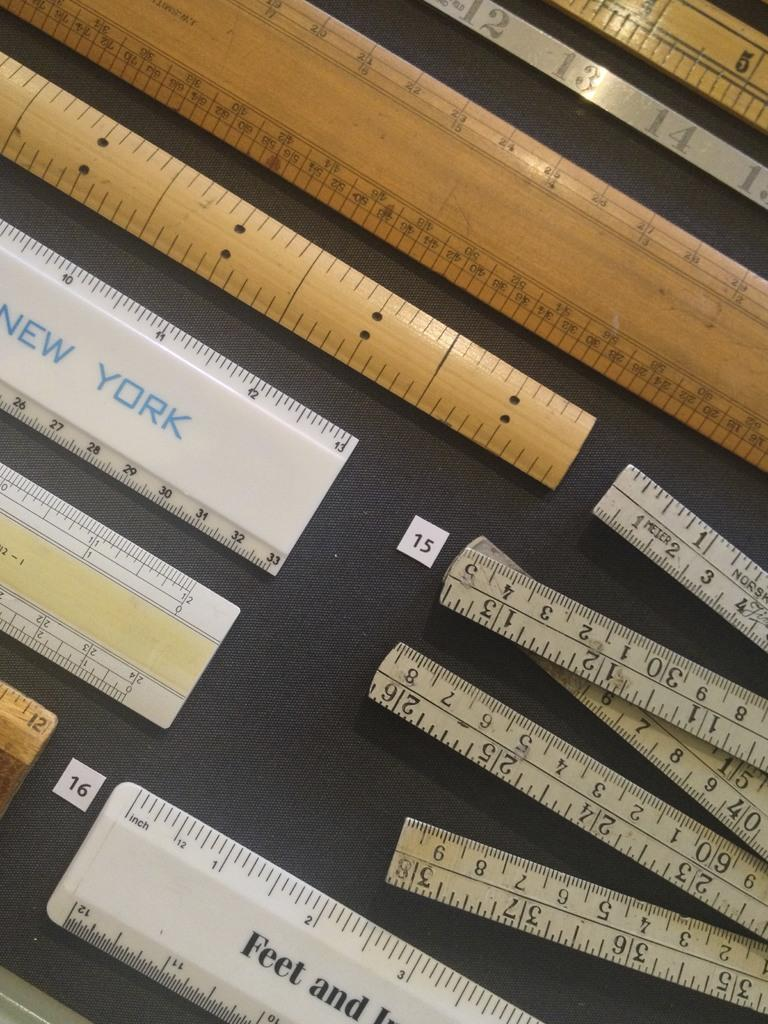<image>
Summarize the visual content of the image. A white ruler with New York printed on it . 